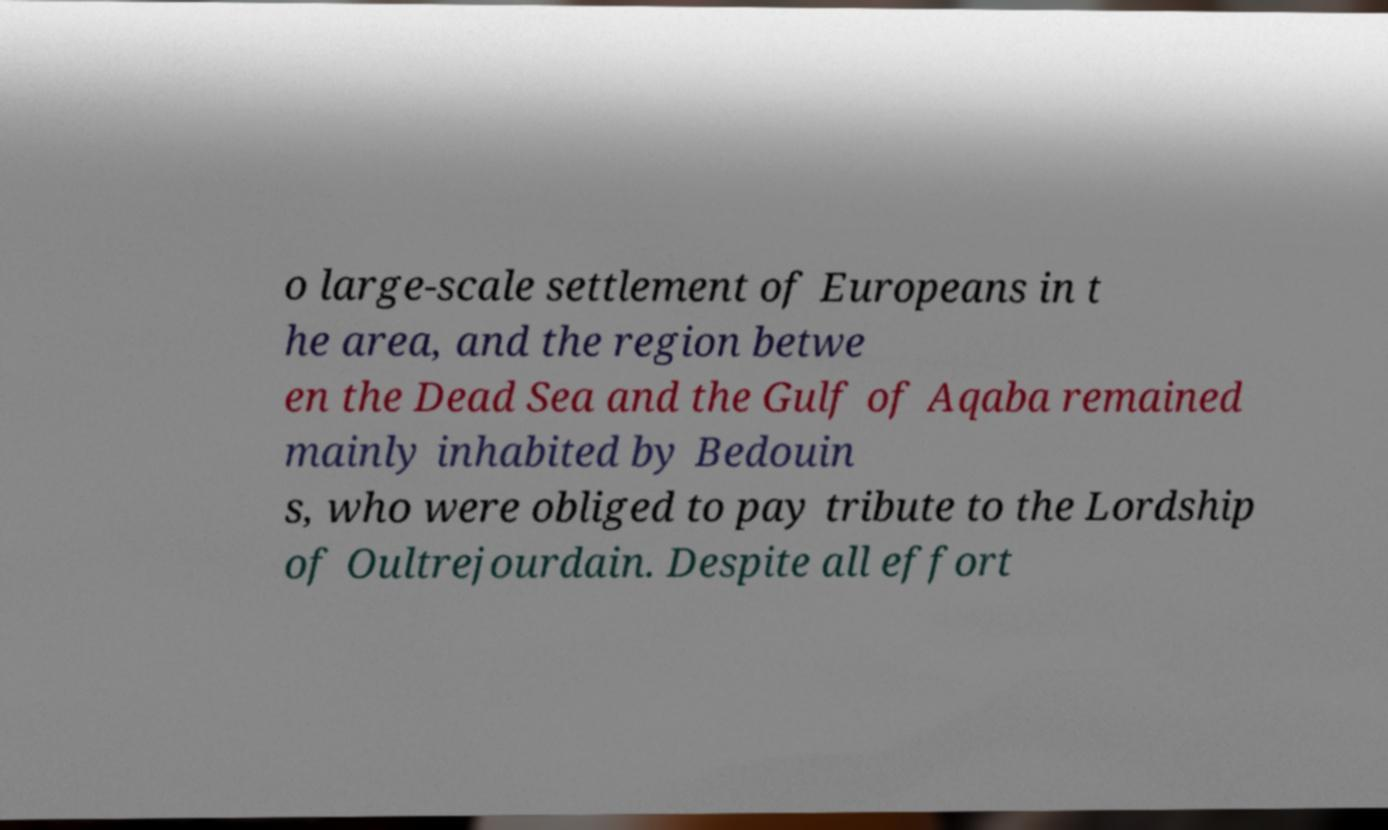I need the written content from this picture converted into text. Can you do that? o large-scale settlement of Europeans in t he area, and the region betwe en the Dead Sea and the Gulf of Aqaba remained mainly inhabited by Bedouin s, who were obliged to pay tribute to the Lordship of Oultrejourdain. Despite all effort 